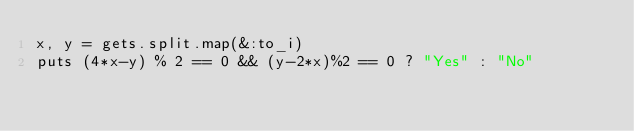Convert code to text. <code><loc_0><loc_0><loc_500><loc_500><_Ruby_>x, y = gets.split.map(&:to_i)
puts (4*x-y) % 2 == 0 && (y-2*x)%2 == 0 ? "Yes" : "No"</code> 